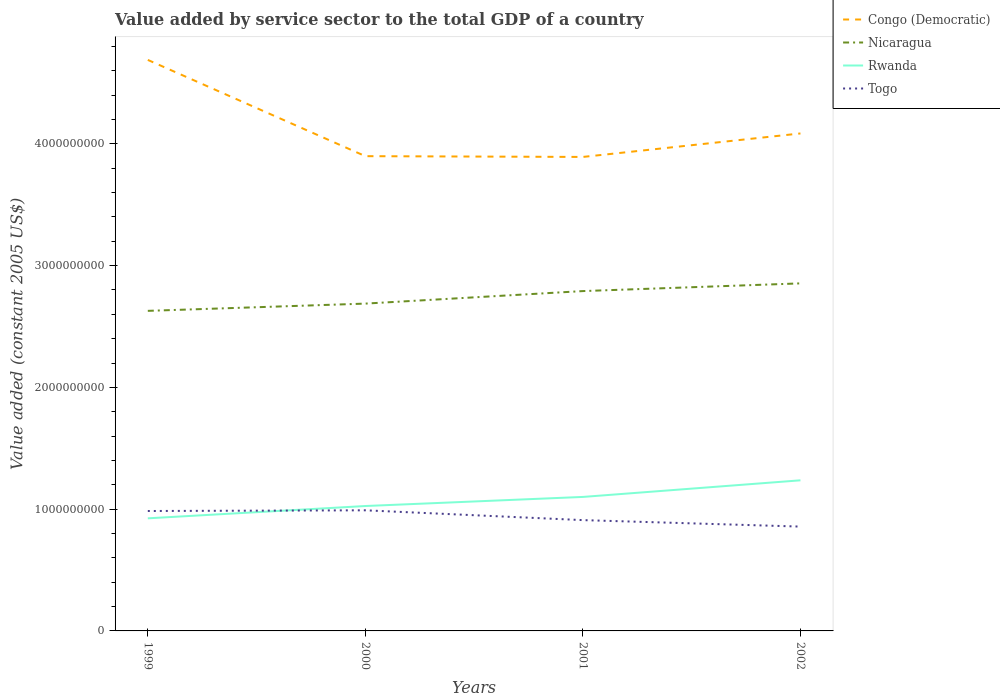How many different coloured lines are there?
Offer a very short reply. 4. Does the line corresponding to Nicaragua intersect with the line corresponding to Togo?
Your response must be concise. No. Is the number of lines equal to the number of legend labels?
Your answer should be very brief. Yes. Across all years, what is the maximum value added by service sector in Togo?
Offer a terse response. 8.57e+08. What is the total value added by service sector in Togo in the graph?
Offer a very short reply. 5.32e+07. What is the difference between the highest and the second highest value added by service sector in Nicaragua?
Your answer should be very brief. 2.26e+08. What is the difference between the highest and the lowest value added by service sector in Togo?
Keep it short and to the point. 2. How many lines are there?
Give a very brief answer. 4. How many years are there in the graph?
Ensure brevity in your answer.  4. Are the values on the major ticks of Y-axis written in scientific E-notation?
Your answer should be very brief. No. Does the graph contain any zero values?
Your response must be concise. No. Does the graph contain grids?
Keep it short and to the point. No. Where does the legend appear in the graph?
Your answer should be compact. Top right. What is the title of the graph?
Offer a terse response. Value added by service sector to the total GDP of a country. What is the label or title of the X-axis?
Offer a very short reply. Years. What is the label or title of the Y-axis?
Ensure brevity in your answer.  Value added (constant 2005 US$). What is the Value added (constant 2005 US$) of Congo (Democratic) in 1999?
Provide a succinct answer. 4.69e+09. What is the Value added (constant 2005 US$) of Nicaragua in 1999?
Provide a short and direct response. 2.63e+09. What is the Value added (constant 2005 US$) in Rwanda in 1999?
Provide a short and direct response. 9.25e+08. What is the Value added (constant 2005 US$) of Togo in 1999?
Keep it short and to the point. 9.85e+08. What is the Value added (constant 2005 US$) of Congo (Democratic) in 2000?
Your response must be concise. 3.90e+09. What is the Value added (constant 2005 US$) of Nicaragua in 2000?
Your answer should be very brief. 2.69e+09. What is the Value added (constant 2005 US$) in Rwanda in 2000?
Give a very brief answer. 1.03e+09. What is the Value added (constant 2005 US$) of Togo in 2000?
Ensure brevity in your answer.  9.91e+08. What is the Value added (constant 2005 US$) of Congo (Democratic) in 2001?
Give a very brief answer. 3.89e+09. What is the Value added (constant 2005 US$) of Nicaragua in 2001?
Offer a terse response. 2.79e+09. What is the Value added (constant 2005 US$) of Rwanda in 2001?
Your answer should be compact. 1.10e+09. What is the Value added (constant 2005 US$) in Togo in 2001?
Offer a very short reply. 9.10e+08. What is the Value added (constant 2005 US$) of Congo (Democratic) in 2002?
Give a very brief answer. 4.09e+09. What is the Value added (constant 2005 US$) in Nicaragua in 2002?
Keep it short and to the point. 2.85e+09. What is the Value added (constant 2005 US$) of Rwanda in 2002?
Your answer should be compact. 1.24e+09. What is the Value added (constant 2005 US$) in Togo in 2002?
Provide a succinct answer. 8.57e+08. Across all years, what is the maximum Value added (constant 2005 US$) of Congo (Democratic)?
Offer a terse response. 4.69e+09. Across all years, what is the maximum Value added (constant 2005 US$) of Nicaragua?
Give a very brief answer. 2.85e+09. Across all years, what is the maximum Value added (constant 2005 US$) of Rwanda?
Offer a very short reply. 1.24e+09. Across all years, what is the maximum Value added (constant 2005 US$) in Togo?
Give a very brief answer. 9.91e+08. Across all years, what is the minimum Value added (constant 2005 US$) in Congo (Democratic)?
Your answer should be very brief. 3.89e+09. Across all years, what is the minimum Value added (constant 2005 US$) in Nicaragua?
Provide a succinct answer. 2.63e+09. Across all years, what is the minimum Value added (constant 2005 US$) of Rwanda?
Your answer should be very brief. 9.25e+08. Across all years, what is the minimum Value added (constant 2005 US$) of Togo?
Your response must be concise. 8.57e+08. What is the total Value added (constant 2005 US$) of Congo (Democratic) in the graph?
Your answer should be very brief. 1.66e+1. What is the total Value added (constant 2005 US$) of Nicaragua in the graph?
Ensure brevity in your answer.  1.10e+1. What is the total Value added (constant 2005 US$) in Rwanda in the graph?
Offer a terse response. 4.29e+09. What is the total Value added (constant 2005 US$) of Togo in the graph?
Your answer should be very brief. 3.74e+09. What is the difference between the Value added (constant 2005 US$) of Congo (Democratic) in 1999 and that in 2000?
Give a very brief answer. 7.91e+08. What is the difference between the Value added (constant 2005 US$) in Nicaragua in 1999 and that in 2000?
Your answer should be compact. -5.96e+07. What is the difference between the Value added (constant 2005 US$) of Rwanda in 1999 and that in 2000?
Ensure brevity in your answer.  -1.01e+08. What is the difference between the Value added (constant 2005 US$) in Togo in 1999 and that in 2000?
Keep it short and to the point. -5.67e+06. What is the difference between the Value added (constant 2005 US$) of Congo (Democratic) in 1999 and that in 2001?
Provide a short and direct response. 7.97e+08. What is the difference between the Value added (constant 2005 US$) of Nicaragua in 1999 and that in 2001?
Ensure brevity in your answer.  -1.62e+08. What is the difference between the Value added (constant 2005 US$) of Rwanda in 1999 and that in 2001?
Provide a short and direct response. -1.76e+08. What is the difference between the Value added (constant 2005 US$) of Togo in 1999 and that in 2001?
Provide a short and direct response. 7.49e+07. What is the difference between the Value added (constant 2005 US$) in Congo (Democratic) in 1999 and that in 2002?
Offer a very short reply. 6.04e+08. What is the difference between the Value added (constant 2005 US$) of Nicaragua in 1999 and that in 2002?
Provide a succinct answer. -2.26e+08. What is the difference between the Value added (constant 2005 US$) of Rwanda in 1999 and that in 2002?
Ensure brevity in your answer.  -3.12e+08. What is the difference between the Value added (constant 2005 US$) in Togo in 1999 and that in 2002?
Provide a short and direct response. 1.28e+08. What is the difference between the Value added (constant 2005 US$) in Congo (Democratic) in 2000 and that in 2001?
Make the answer very short. 6.30e+06. What is the difference between the Value added (constant 2005 US$) in Nicaragua in 2000 and that in 2001?
Give a very brief answer. -1.03e+08. What is the difference between the Value added (constant 2005 US$) in Rwanda in 2000 and that in 2001?
Make the answer very short. -7.47e+07. What is the difference between the Value added (constant 2005 US$) in Togo in 2000 and that in 2001?
Your answer should be very brief. 8.05e+07. What is the difference between the Value added (constant 2005 US$) in Congo (Democratic) in 2000 and that in 2002?
Your answer should be compact. -1.87e+08. What is the difference between the Value added (constant 2005 US$) in Nicaragua in 2000 and that in 2002?
Make the answer very short. -1.66e+08. What is the difference between the Value added (constant 2005 US$) in Rwanda in 2000 and that in 2002?
Offer a very short reply. -2.11e+08. What is the difference between the Value added (constant 2005 US$) in Togo in 2000 and that in 2002?
Offer a terse response. 1.34e+08. What is the difference between the Value added (constant 2005 US$) of Congo (Democratic) in 2001 and that in 2002?
Your answer should be very brief. -1.93e+08. What is the difference between the Value added (constant 2005 US$) in Nicaragua in 2001 and that in 2002?
Your response must be concise. -6.33e+07. What is the difference between the Value added (constant 2005 US$) in Rwanda in 2001 and that in 2002?
Provide a succinct answer. -1.36e+08. What is the difference between the Value added (constant 2005 US$) of Togo in 2001 and that in 2002?
Provide a succinct answer. 5.32e+07. What is the difference between the Value added (constant 2005 US$) in Congo (Democratic) in 1999 and the Value added (constant 2005 US$) in Nicaragua in 2000?
Make the answer very short. 2.00e+09. What is the difference between the Value added (constant 2005 US$) of Congo (Democratic) in 1999 and the Value added (constant 2005 US$) of Rwanda in 2000?
Give a very brief answer. 3.66e+09. What is the difference between the Value added (constant 2005 US$) in Congo (Democratic) in 1999 and the Value added (constant 2005 US$) in Togo in 2000?
Your answer should be compact. 3.70e+09. What is the difference between the Value added (constant 2005 US$) in Nicaragua in 1999 and the Value added (constant 2005 US$) in Rwanda in 2000?
Your answer should be compact. 1.60e+09. What is the difference between the Value added (constant 2005 US$) in Nicaragua in 1999 and the Value added (constant 2005 US$) in Togo in 2000?
Keep it short and to the point. 1.64e+09. What is the difference between the Value added (constant 2005 US$) in Rwanda in 1999 and the Value added (constant 2005 US$) in Togo in 2000?
Give a very brief answer. -6.58e+07. What is the difference between the Value added (constant 2005 US$) in Congo (Democratic) in 1999 and the Value added (constant 2005 US$) in Nicaragua in 2001?
Offer a very short reply. 1.90e+09. What is the difference between the Value added (constant 2005 US$) in Congo (Democratic) in 1999 and the Value added (constant 2005 US$) in Rwanda in 2001?
Keep it short and to the point. 3.59e+09. What is the difference between the Value added (constant 2005 US$) in Congo (Democratic) in 1999 and the Value added (constant 2005 US$) in Togo in 2001?
Provide a succinct answer. 3.78e+09. What is the difference between the Value added (constant 2005 US$) in Nicaragua in 1999 and the Value added (constant 2005 US$) in Rwanda in 2001?
Your answer should be compact. 1.53e+09. What is the difference between the Value added (constant 2005 US$) in Nicaragua in 1999 and the Value added (constant 2005 US$) in Togo in 2001?
Your answer should be very brief. 1.72e+09. What is the difference between the Value added (constant 2005 US$) of Rwanda in 1999 and the Value added (constant 2005 US$) of Togo in 2001?
Give a very brief answer. 1.47e+07. What is the difference between the Value added (constant 2005 US$) in Congo (Democratic) in 1999 and the Value added (constant 2005 US$) in Nicaragua in 2002?
Your answer should be very brief. 1.84e+09. What is the difference between the Value added (constant 2005 US$) in Congo (Democratic) in 1999 and the Value added (constant 2005 US$) in Rwanda in 2002?
Offer a terse response. 3.45e+09. What is the difference between the Value added (constant 2005 US$) of Congo (Democratic) in 1999 and the Value added (constant 2005 US$) of Togo in 2002?
Your answer should be very brief. 3.83e+09. What is the difference between the Value added (constant 2005 US$) of Nicaragua in 1999 and the Value added (constant 2005 US$) of Rwanda in 2002?
Your response must be concise. 1.39e+09. What is the difference between the Value added (constant 2005 US$) in Nicaragua in 1999 and the Value added (constant 2005 US$) in Togo in 2002?
Offer a terse response. 1.77e+09. What is the difference between the Value added (constant 2005 US$) in Rwanda in 1999 and the Value added (constant 2005 US$) in Togo in 2002?
Offer a very short reply. 6.79e+07. What is the difference between the Value added (constant 2005 US$) of Congo (Democratic) in 2000 and the Value added (constant 2005 US$) of Nicaragua in 2001?
Make the answer very short. 1.11e+09. What is the difference between the Value added (constant 2005 US$) of Congo (Democratic) in 2000 and the Value added (constant 2005 US$) of Rwanda in 2001?
Offer a very short reply. 2.80e+09. What is the difference between the Value added (constant 2005 US$) in Congo (Democratic) in 2000 and the Value added (constant 2005 US$) in Togo in 2001?
Ensure brevity in your answer.  2.99e+09. What is the difference between the Value added (constant 2005 US$) of Nicaragua in 2000 and the Value added (constant 2005 US$) of Rwanda in 2001?
Offer a very short reply. 1.59e+09. What is the difference between the Value added (constant 2005 US$) in Nicaragua in 2000 and the Value added (constant 2005 US$) in Togo in 2001?
Keep it short and to the point. 1.78e+09. What is the difference between the Value added (constant 2005 US$) of Rwanda in 2000 and the Value added (constant 2005 US$) of Togo in 2001?
Your response must be concise. 1.16e+08. What is the difference between the Value added (constant 2005 US$) of Congo (Democratic) in 2000 and the Value added (constant 2005 US$) of Nicaragua in 2002?
Your answer should be compact. 1.04e+09. What is the difference between the Value added (constant 2005 US$) of Congo (Democratic) in 2000 and the Value added (constant 2005 US$) of Rwanda in 2002?
Offer a terse response. 2.66e+09. What is the difference between the Value added (constant 2005 US$) in Congo (Democratic) in 2000 and the Value added (constant 2005 US$) in Togo in 2002?
Offer a very short reply. 3.04e+09. What is the difference between the Value added (constant 2005 US$) in Nicaragua in 2000 and the Value added (constant 2005 US$) in Rwanda in 2002?
Offer a very short reply. 1.45e+09. What is the difference between the Value added (constant 2005 US$) in Nicaragua in 2000 and the Value added (constant 2005 US$) in Togo in 2002?
Ensure brevity in your answer.  1.83e+09. What is the difference between the Value added (constant 2005 US$) of Rwanda in 2000 and the Value added (constant 2005 US$) of Togo in 2002?
Offer a very short reply. 1.69e+08. What is the difference between the Value added (constant 2005 US$) of Congo (Democratic) in 2001 and the Value added (constant 2005 US$) of Nicaragua in 2002?
Keep it short and to the point. 1.04e+09. What is the difference between the Value added (constant 2005 US$) of Congo (Democratic) in 2001 and the Value added (constant 2005 US$) of Rwanda in 2002?
Your answer should be compact. 2.66e+09. What is the difference between the Value added (constant 2005 US$) in Congo (Democratic) in 2001 and the Value added (constant 2005 US$) in Togo in 2002?
Give a very brief answer. 3.04e+09. What is the difference between the Value added (constant 2005 US$) of Nicaragua in 2001 and the Value added (constant 2005 US$) of Rwanda in 2002?
Ensure brevity in your answer.  1.55e+09. What is the difference between the Value added (constant 2005 US$) in Nicaragua in 2001 and the Value added (constant 2005 US$) in Togo in 2002?
Your answer should be very brief. 1.93e+09. What is the difference between the Value added (constant 2005 US$) in Rwanda in 2001 and the Value added (constant 2005 US$) in Togo in 2002?
Offer a very short reply. 2.44e+08. What is the average Value added (constant 2005 US$) in Congo (Democratic) per year?
Keep it short and to the point. 4.14e+09. What is the average Value added (constant 2005 US$) of Nicaragua per year?
Give a very brief answer. 2.74e+09. What is the average Value added (constant 2005 US$) of Rwanda per year?
Make the answer very short. 1.07e+09. What is the average Value added (constant 2005 US$) of Togo per year?
Your response must be concise. 9.36e+08. In the year 1999, what is the difference between the Value added (constant 2005 US$) of Congo (Democratic) and Value added (constant 2005 US$) of Nicaragua?
Offer a very short reply. 2.06e+09. In the year 1999, what is the difference between the Value added (constant 2005 US$) of Congo (Democratic) and Value added (constant 2005 US$) of Rwanda?
Give a very brief answer. 3.76e+09. In the year 1999, what is the difference between the Value added (constant 2005 US$) in Congo (Democratic) and Value added (constant 2005 US$) in Togo?
Give a very brief answer. 3.70e+09. In the year 1999, what is the difference between the Value added (constant 2005 US$) of Nicaragua and Value added (constant 2005 US$) of Rwanda?
Ensure brevity in your answer.  1.70e+09. In the year 1999, what is the difference between the Value added (constant 2005 US$) of Nicaragua and Value added (constant 2005 US$) of Togo?
Give a very brief answer. 1.64e+09. In the year 1999, what is the difference between the Value added (constant 2005 US$) in Rwanda and Value added (constant 2005 US$) in Togo?
Your response must be concise. -6.02e+07. In the year 2000, what is the difference between the Value added (constant 2005 US$) of Congo (Democratic) and Value added (constant 2005 US$) of Nicaragua?
Ensure brevity in your answer.  1.21e+09. In the year 2000, what is the difference between the Value added (constant 2005 US$) of Congo (Democratic) and Value added (constant 2005 US$) of Rwanda?
Offer a terse response. 2.87e+09. In the year 2000, what is the difference between the Value added (constant 2005 US$) in Congo (Democratic) and Value added (constant 2005 US$) in Togo?
Make the answer very short. 2.91e+09. In the year 2000, what is the difference between the Value added (constant 2005 US$) in Nicaragua and Value added (constant 2005 US$) in Rwanda?
Provide a succinct answer. 1.66e+09. In the year 2000, what is the difference between the Value added (constant 2005 US$) in Nicaragua and Value added (constant 2005 US$) in Togo?
Ensure brevity in your answer.  1.70e+09. In the year 2000, what is the difference between the Value added (constant 2005 US$) of Rwanda and Value added (constant 2005 US$) of Togo?
Offer a terse response. 3.53e+07. In the year 2001, what is the difference between the Value added (constant 2005 US$) in Congo (Democratic) and Value added (constant 2005 US$) in Nicaragua?
Your response must be concise. 1.10e+09. In the year 2001, what is the difference between the Value added (constant 2005 US$) of Congo (Democratic) and Value added (constant 2005 US$) of Rwanda?
Provide a short and direct response. 2.79e+09. In the year 2001, what is the difference between the Value added (constant 2005 US$) in Congo (Democratic) and Value added (constant 2005 US$) in Togo?
Give a very brief answer. 2.98e+09. In the year 2001, what is the difference between the Value added (constant 2005 US$) of Nicaragua and Value added (constant 2005 US$) of Rwanda?
Your answer should be very brief. 1.69e+09. In the year 2001, what is the difference between the Value added (constant 2005 US$) in Nicaragua and Value added (constant 2005 US$) in Togo?
Your answer should be very brief. 1.88e+09. In the year 2001, what is the difference between the Value added (constant 2005 US$) of Rwanda and Value added (constant 2005 US$) of Togo?
Give a very brief answer. 1.90e+08. In the year 2002, what is the difference between the Value added (constant 2005 US$) in Congo (Democratic) and Value added (constant 2005 US$) in Nicaragua?
Your response must be concise. 1.23e+09. In the year 2002, what is the difference between the Value added (constant 2005 US$) in Congo (Democratic) and Value added (constant 2005 US$) in Rwanda?
Your answer should be very brief. 2.85e+09. In the year 2002, what is the difference between the Value added (constant 2005 US$) of Congo (Democratic) and Value added (constant 2005 US$) of Togo?
Your answer should be compact. 3.23e+09. In the year 2002, what is the difference between the Value added (constant 2005 US$) in Nicaragua and Value added (constant 2005 US$) in Rwanda?
Offer a very short reply. 1.62e+09. In the year 2002, what is the difference between the Value added (constant 2005 US$) in Nicaragua and Value added (constant 2005 US$) in Togo?
Your answer should be compact. 2.00e+09. In the year 2002, what is the difference between the Value added (constant 2005 US$) of Rwanda and Value added (constant 2005 US$) of Togo?
Your answer should be very brief. 3.80e+08. What is the ratio of the Value added (constant 2005 US$) of Congo (Democratic) in 1999 to that in 2000?
Provide a short and direct response. 1.2. What is the ratio of the Value added (constant 2005 US$) of Nicaragua in 1999 to that in 2000?
Provide a succinct answer. 0.98. What is the ratio of the Value added (constant 2005 US$) of Rwanda in 1999 to that in 2000?
Your answer should be compact. 0.9. What is the ratio of the Value added (constant 2005 US$) of Togo in 1999 to that in 2000?
Your response must be concise. 0.99. What is the ratio of the Value added (constant 2005 US$) in Congo (Democratic) in 1999 to that in 2001?
Your answer should be very brief. 1.2. What is the ratio of the Value added (constant 2005 US$) in Nicaragua in 1999 to that in 2001?
Offer a very short reply. 0.94. What is the ratio of the Value added (constant 2005 US$) of Rwanda in 1999 to that in 2001?
Your answer should be very brief. 0.84. What is the ratio of the Value added (constant 2005 US$) in Togo in 1999 to that in 2001?
Your response must be concise. 1.08. What is the ratio of the Value added (constant 2005 US$) in Congo (Democratic) in 1999 to that in 2002?
Keep it short and to the point. 1.15. What is the ratio of the Value added (constant 2005 US$) of Nicaragua in 1999 to that in 2002?
Offer a very short reply. 0.92. What is the ratio of the Value added (constant 2005 US$) of Rwanda in 1999 to that in 2002?
Your answer should be very brief. 0.75. What is the ratio of the Value added (constant 2005 US$) of Togo in 1999 to that in 2002?
Your answer should be compact. 1.15. What is the ratio of the Value added (constant 2005 US$) of Nicaragua in 2000 to that in 2001?
Provide a short and direct response. 0.96. What is the ratio of the Value added (constant 2005 US$) of Rwanda in 2000 to that in 2001?
Provide a succinct answer. 0.93. What is the ratio of the Value added (constant 2005 US$) in Togo in 2000 to that in 2001?
Your response must be concise. 1.09. What is the ratio of the Value added (constant 2005 US$) of Congo (Democratic) in 2000 to that in 2002?
Give a very brief answer. 0.95. What is the ratio of the Value added (constant 2005 US$) in Nicaragua in 2000 to that in 2002?
Give a very brief answer. 0.94. What is the ratio of the Value added (constant 2005 US$) in Rwanda in 2000 to that in 2002?
Your answer should be very brief. 0.83. What is the ratio of the Value added (constant 2005 US$) of Togo in 2000 to that in 2002?
Offer a terse response. 1.16. What is the ratio of the Value added (constant 2005 US$) of Congo (Democratic) in 2001 to that in 2002?
Give a very brief answer. 0.95. What is the ratio of the Value added (constant 2005 US$) in Nicaragua in 2001 to that in 2002?
Your response must be concise. 0.98. What is the ratio of the Value added (constant 2005 US$) in Rwanda in 2001 to that in 2002?
Keep it short and to the point. 0.89. What is the ratio of the Value added (constant 2005 US$) in Togo in 2001 to that in 2002?
Your answer should be very brief. 1.06. What is the difference between the highest and the second highest Value added (constant 2005 US$) of Congo (Democratic)?
Your response must be concise. 6.04e+08. What is the difference between the highest and the second highest Value added (constant 2005 US$) of Nicaragua?
Provide a short and direct response. 6.33e+07. What is the difference between the highest and the second highest Value added (constant 2005 US$) in Rwanda?
Ensure brevity in your answer.  1.36e+08. What is the difference between the highest and the second highest Value added (constant 2005 US$) in Togo?
Keep it short and to the point. 5.67e+06. What is the difference between the highest and the lowest Value added (constant 2005 US$) in Congo (Democratic)?
Ensure brevity in your answer.  7.97e+08. What is the difference between the highest and the lowest Value added (constant 2005 US$) of Nicaragua?
Your answer should be very brief. 2.26e+08. What is the difference between the highest and the lowest Value added (constant 2005 US$) of Rwanda?
Ensure brevity in your answer.  3.12e+08. What is the difference between the highest and the lowest Value added (constant 2005 US$) in Togo?
Keep it short and to the point. 1.34e+08. 